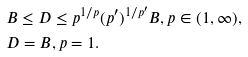<formula> <loc_0><loc_0><loc_500><loc_500>& B \leq D \leq p ^ { 1 / p } ( p ^ { \prime } ) ^ { 1 / p ^ { \prime } } B , p \in ( 1 , \infty ) , \\ & D = B , p = 1 .</formula> 